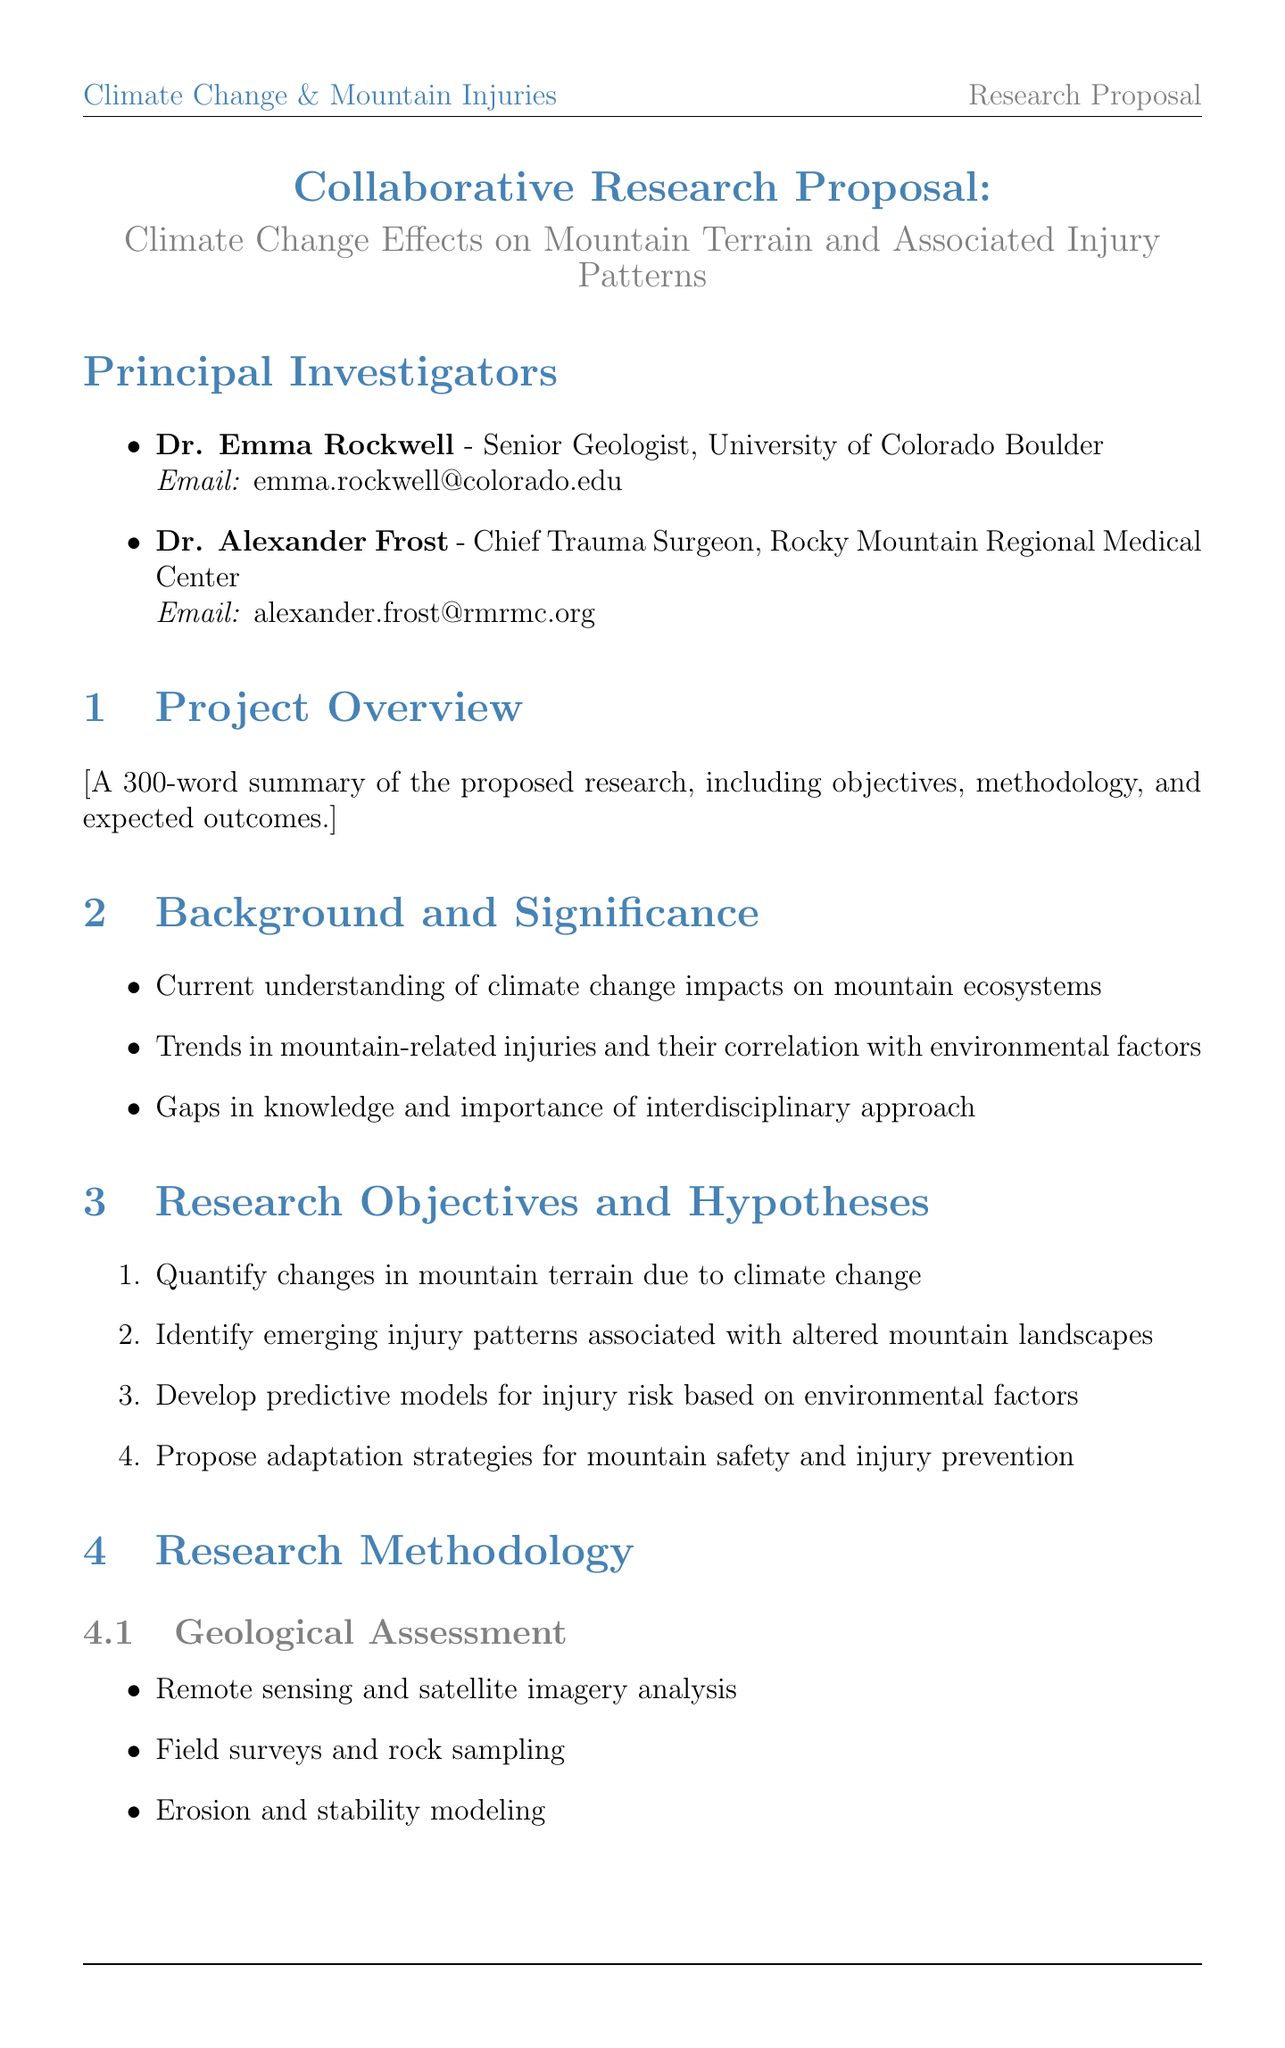What is the title of the project? The title of the project is provided in the document, which is "Climate Change Effects on Mountain Terrain and Associated Injury Patterns."
Answer: Climate Change Effects on Mountain Terrain and Associated Injury Patterns Who are the principal investigators? The document lists the names of the principal investigators, which are Dr. Emma Rockwell and Dr. Alexander Frost.
Answer: Dr. Emma Rockwell and Dr. Alexander Frost What is the total requested funding? The total requested funding is mentioned in the budget overview of the document.
Answer: $750,000 How long is Phase 2 of the project? The duration of Phase 2 is specified in the project timeline section of the document.
Answer: 18 months What is one method used in the Geological Assessment? The document lists methods used in the Geological Assessment section, including "Remote sensing and satellite imagery analysis."
Answer: Remote sensing and satellite imagery analysis What is one expected outcome of the research? The document outlines expected outcomes, such as "Comprehensive mapping of climate-induced changes in mountain terrain."
Answer: Comprehensive mapping of climate-induced changes in mountain terrain What ethical consideration is mentioned regarding medical data analysis? The document mentions an ethical consideration related to medical data analysis, specifically "Institutional Review Board (IRB) approval for medical data analysis."
Answer: Institutional Review Board (IRB) approval for medical data analysis Which institution is responsible for climate data provision? The document identifies collaborating institutions, where the "National Center for Atmospheric Research" is responsible for climate data provision.
Answer: National Center for Atmospheric Research 